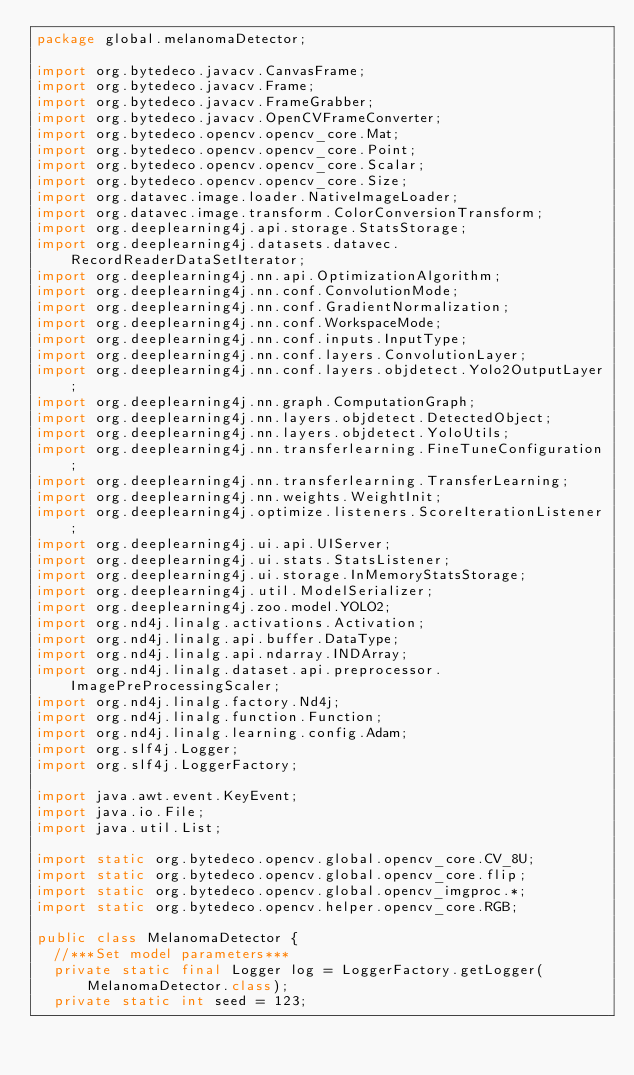<code> <loc_0><loc_0><loc_500><loc_500><_Java_>package global.melanomaDetector;

import org.bytedeco.javacv.CanvasFrame;
import org.bytedeco.javacv.Frame;
import org.bytedeco.javacv.FrameGrabber;
import org.bytedeco.javacv.OpenCVFrameConverter;
import org.bytedeco.opencv.opencv_core.Mat;
import org.bytedeco.opencv.opencv_core.Point;
import org.bytedeco.opencv.opencv_core.Scalar;
import org.bytedeco.opencv.opencv_core.Size;
import org.datavec.image.loader.NativeImageLoader;
import org.datavec.image.transform.ColorConversionTransform;
import org.deeplearning4j.api.storage.StatsStorage;
import org.deeplearning4j.datasets.datavec.RecordReaderDataSetIterator;
import org.deeplearning4j.nn.api.OptimizationAlgorithm;
import org.deeplearning4j.nn.conf.ConvolutionMode;
import org.deeplearning4j.nn.conf.GradientNormalization;
import org.deeplearning4j.nn.conf.WorkspaceMode;
import org.deeplearning4j.nn.conf.inputs.InputType;
import org.deeplearning4j.nn.conf.layers.ConvolutionLayer;
import org.deeplearning4j.nn.conf.layers.objdetect.Yolo2OutputLayer;
import org.deeplearning4j.nn.graph.ComputationGraph;
import org.deeplearning4j.nn.layers.objdetect.DetectedObject;
import org.deeplearning4j.nn.layers.objdetect.YoloUtils;
import org.deeplearning4j.nn.transferlearning.FineTuneConfiguration;
import org.deeplearning4j.nn.transferlearning.TransferLearning;
import org.deeplearning4j.nn.weights.WeightInit;
import org.deeplearning4j.optimize.listeners.ScoreIterationListener;
import org.deeplearning4j.ui.api.UIServer;
import org.deeplearning4j.ui.stats.StatsListener;
import org.deeplearning4j.ui.storage.InMemoryStatsStorage;
import org.deeplearning4j.util.ModelSerializer;
import org.deeplearning4j.zoo.model.YOLO2;
import org.nd4j.linalg.activations.Activation;
import org.nd4j.linalg.api.buffer.DataType;
import org.nd4j.linalg.api.ndarray.INDArray;
import org.nd4j.linalg.dataset.api.preprocessor.ImagePreProcessingScaler;
import org.nd4j.linalg.factory.Nd4j;
import org.nd4j.linalg.function.Function;
import org.nd4j.linalg.learning.config.Adam;
import org.slf4j.Logger;
import org.slf4j.LoggerFactory;

import java.awt.event.KeyEvent;
import java.io.File;
import java.util.List;

import static org.bytedeco.opencv.global.opencv_core.CV_8U;
import static org.bytedeco.opencv.global.opencv_core.flip;
import static org.bytedeco.opencv.global.opencv_imgproc.*;
import static org.bytedeco.opencv.helper.opencv_core.RGB;

public class MelanomaDetector {
  //***Set model parameters***
  private static final Logger log = LoggerFactory.getLogger(MelanomaDetector.class);
  private static int seed = 123;</code> 